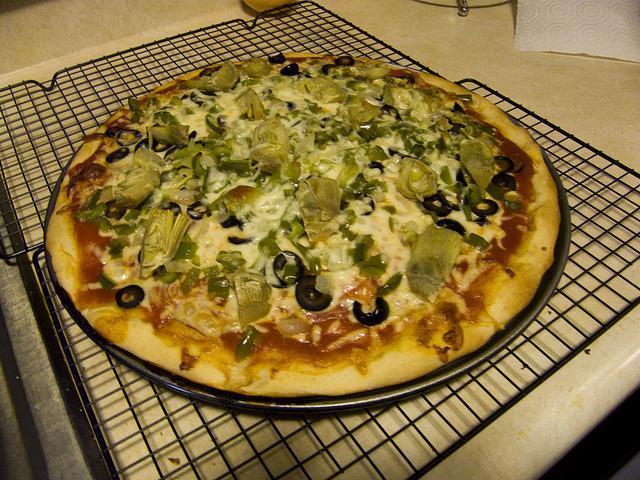How many airplanes are parked here?
Give a very brief answer. 0. 